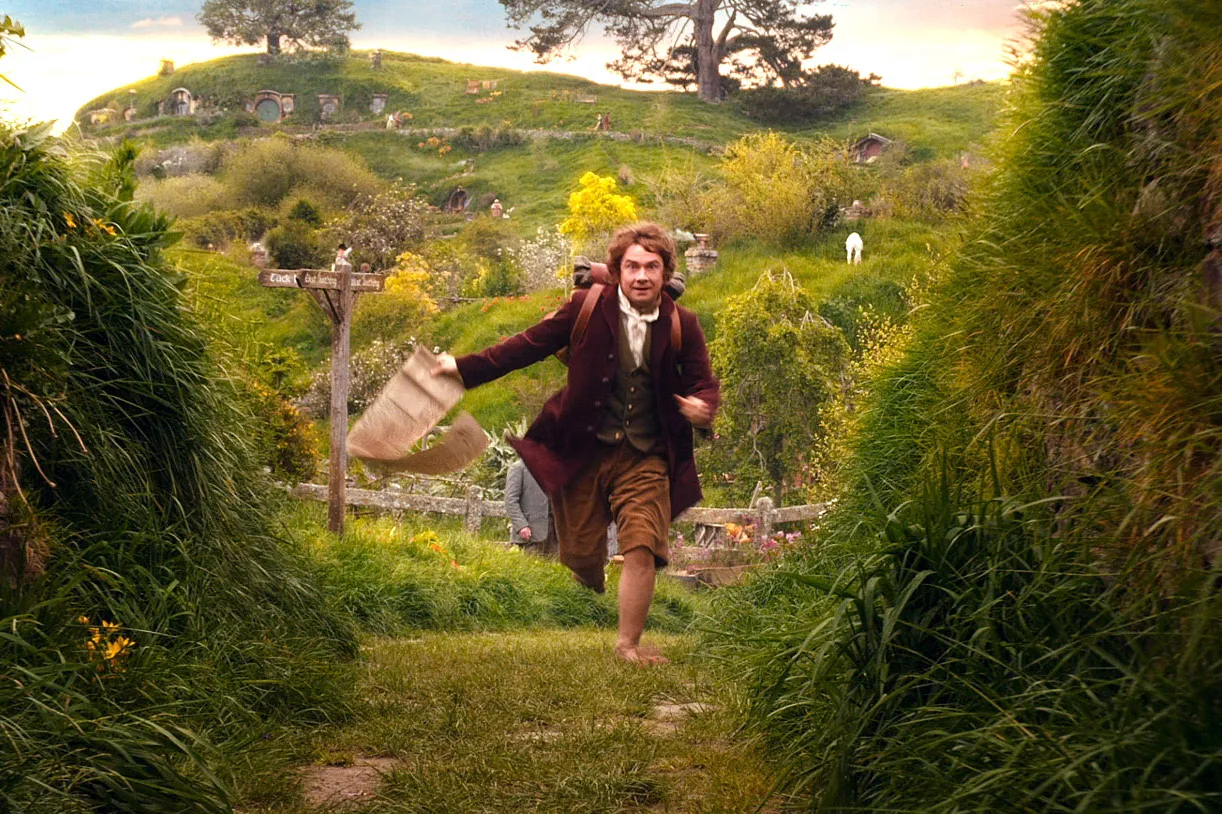What are the key elements in this picture? This image captures a man in motion through the enchanting landscape typical of the Shire, as depicted in 'The Hobbit'. He is dressed in a vintage costume that includes a dark jacket and trousers, indicating a setting from a different era. The vibrant, green scenery with rounded doorways burrowed into the hills highlights the unique architectural styles of the hobbit homes. Prominently, a wooden sign reading 'Bag End' is also visible, placing the scene near the home of the protagonist, Bilbo Baggins. This moment seems packed with action and adventure, suggestive of an urgent journey or mission. 